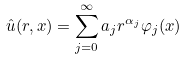<formula> <loc_0><loc_0><loc_500><loc_500>\hat { u } ( r , x ) = \sum _ { j = 0 } ^ { \infty } a _ { j } r ^ { \alpha _ { j } } \varphi _ { j } ( x )</formula> 